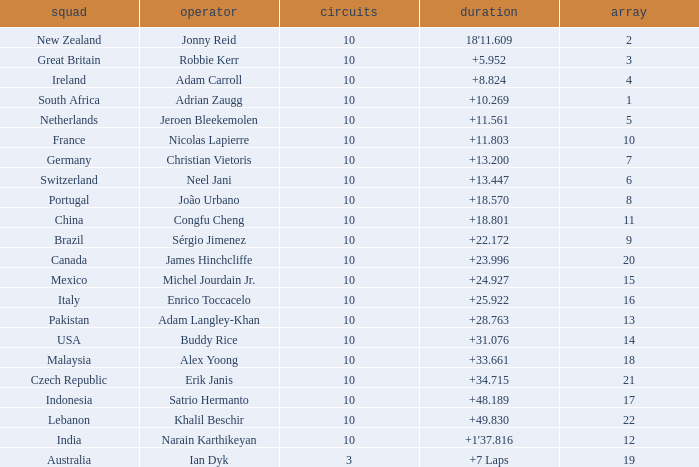What is the Grid number for the Team from Italy? 1.0. 